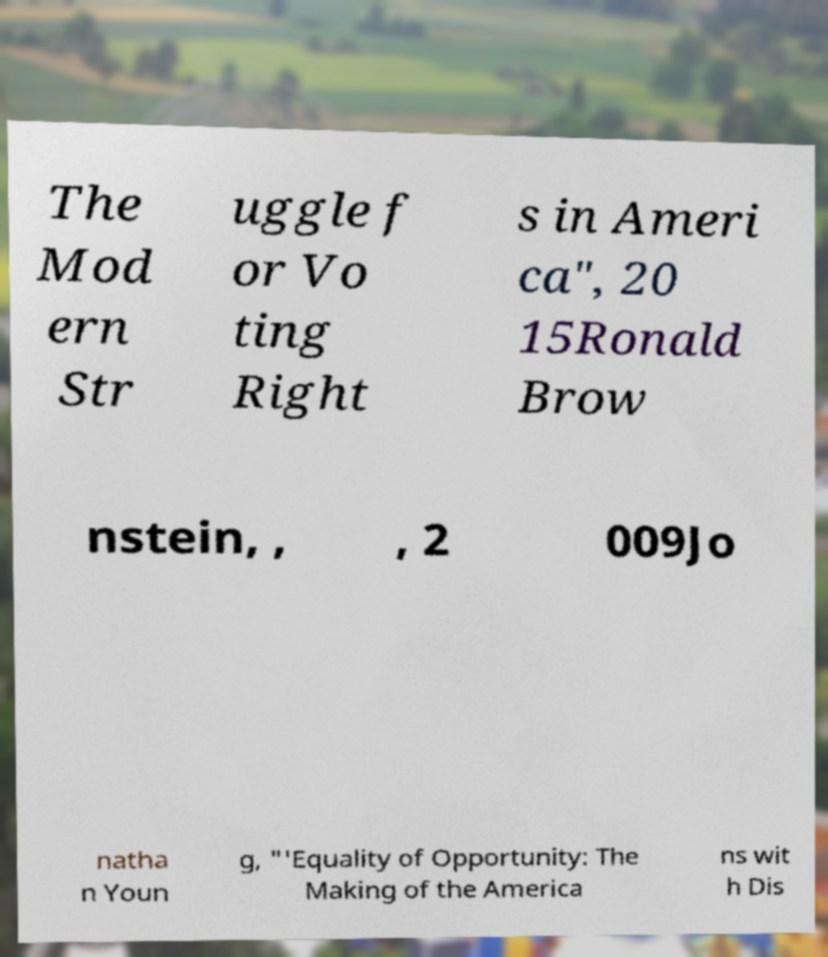Please read and relay the text visible in this image. What does it say? The Mod ern Str uggle f or Vo ting Right s in Ameri ca", 20 15Ronald Brow nstein, , , 2 009Jo natha n Youn g, "'Equality of Opportunity: The Making of the America ns wit h Dis 